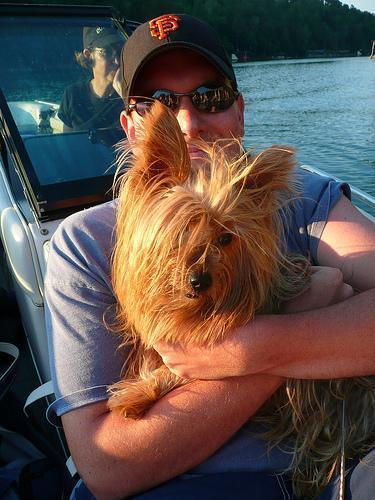How many people are in the picture?
Give a very brief answer. 2. How many people in the picture are wearing black caps?
Give a very brief answer. 2. 